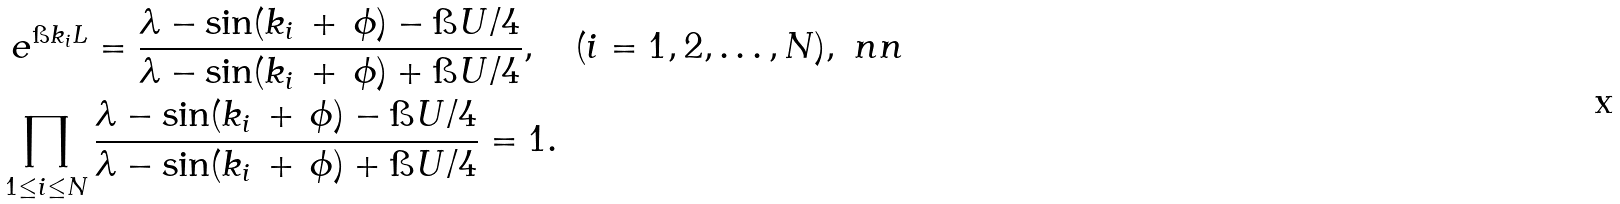<formula> <loc_0><loc_0><loc_500><loc_500>& \ e ^ { \i k _ { i } L } = \frac { \lambda - \sin ( k _ { i } \, + \, \phi ) - \i U / 4 } { \lambda - \sin ( k _ { i } \, + \, \phi ) + \i U / 4 } , \quad ( i = 1 , 2 , \dots , N ) , \ n n \\ & \prod _ { 1 \leq i \leq N } \frac { \lambda - \sin ( k _ { i } \, + \, \phi ) - \i U / 4 } { \lambda - \sin ( k _ { i } \, + \, \phi ) + \i U / 4 } = 1 .</formula> 